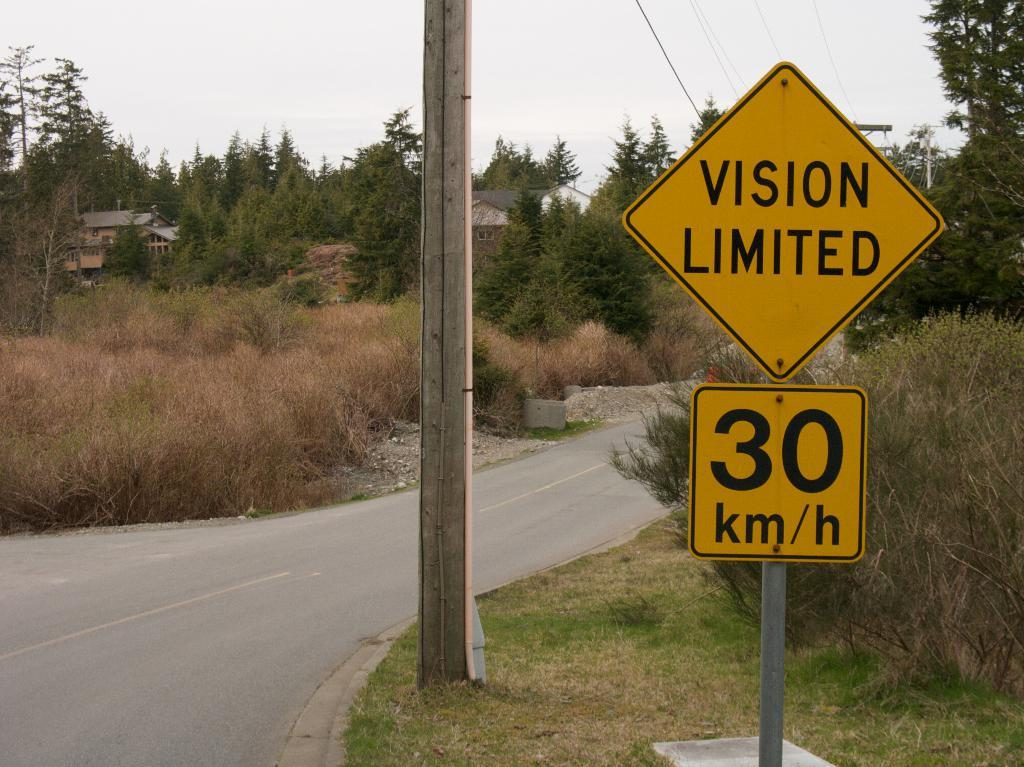<image>
Describe the image concisely. The speed limit on the country road shown in 30 km/h. 